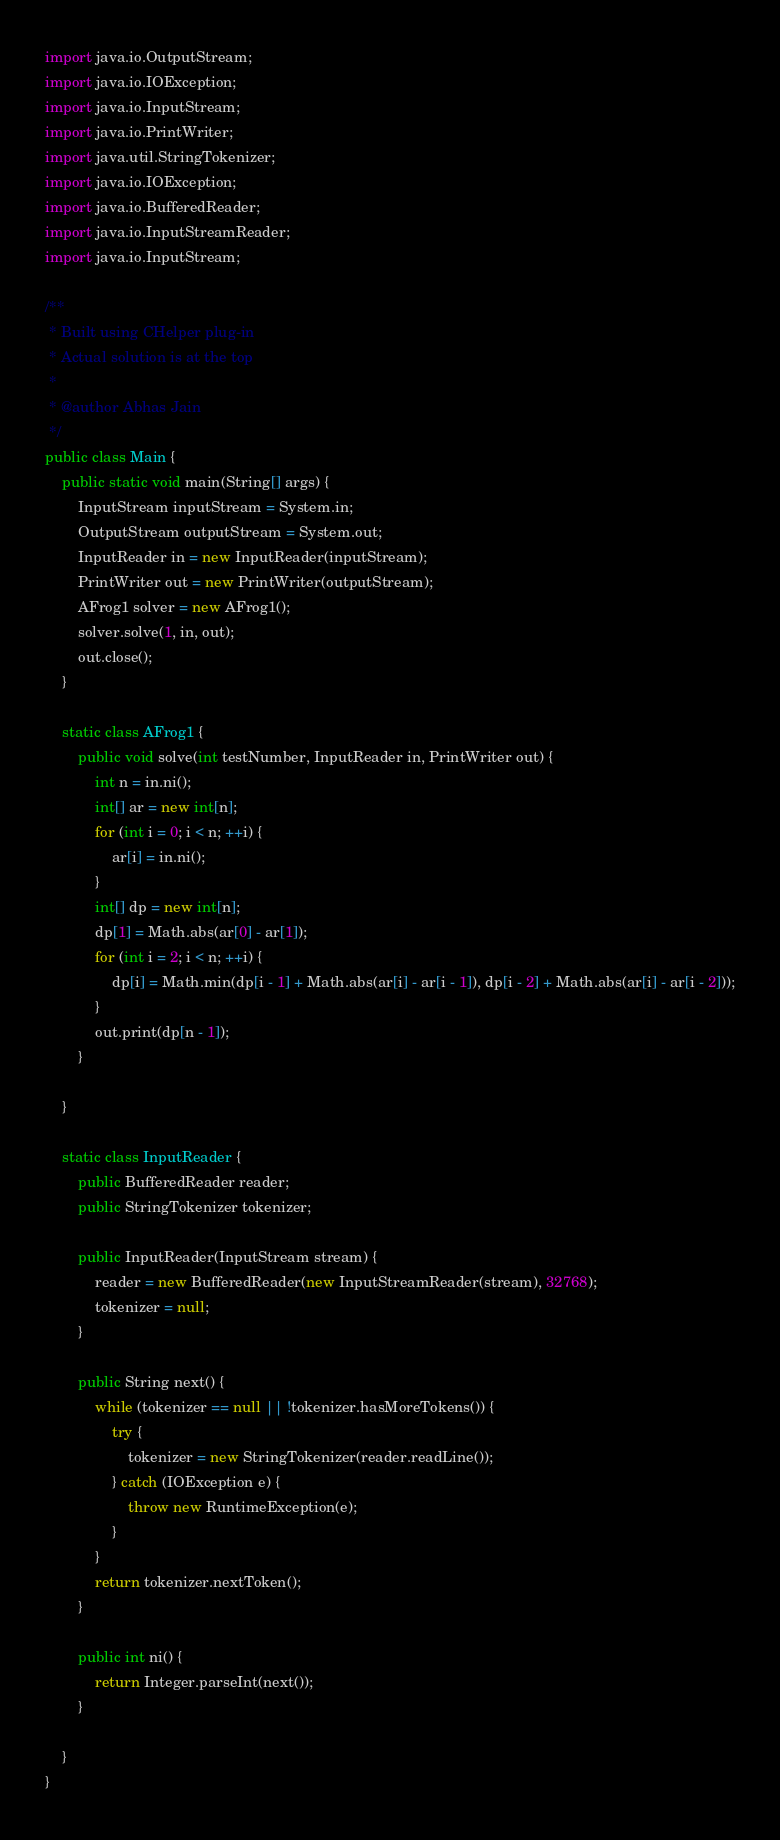Convert code to text. <code><loc_0><loc_0><loc_500><loc_500><_Java_>import java.io.OutputStream;
import java.io.IOException;
import java.io.InputStream;
import java.io.PrintWriter;
import java.util.StringTokenizer;
import java.io.IOException;
import java.io.BufferedReader;
import java.io.InputStreamReader;
import java.io.InputStream;

/**
 * Built using CHelper plug-in
 * Actual solution is at the top
 *
 * @author Abhas Jain
 */
public class Main {
    public static void main(String[] args) {
        InputStream inputStream = System.in;
        OutputStream outputStream = System.out;
        InputReader in = new InputReader(inputStream);
        PrintWriter out = new PrintWriter(outputStream);
        AFrog1 solver = new AFrog1();
        solver.solve(1, in, out);
        out.close();
    }

    static class AFrog1 {
        public void solve(int testNumber, InputReader in, PrintWriter out) {
            int n = in.ni();
            int[] ar = new int[n];
            for (int i = 0; i < n; ++i) {
                ar[i] = in.ni();
            }
            int[] dp = new int[n];
            dp[1] = Math.abs(ar[0] - ar[1]);
            for (int i = 2; i < n; ++i) {
                dp[i] = Math.min(dp[i - 1] + Math.abs(ar[i] - ar[i - 1]), dp[i - 2] + Math.abs(ar[i] - ar[i - 2]));
            }
            out.print(dp[n - 1]);
        }

    }

    static class InputReader {
        public BufferedReader reader;
        public StringTokenizer tokenizer;

        public InputReader(InputStream stream) {
            reader = new BufferedReader(new InputStreamReader(stream), 32768);
            tokenizer = null;
        }

        public String next() {
            while (tokenizer == null || !tokenizer.hasMoreTokens()) {
                try {
                    tokenizer = new StringTokenizer(reader.readLine());
                } catch (IOException e) {
                    throw new RuntimeException(e);
                }
            }
            return tokenizer.nextToken();
        }

        public int ni() {
            return Integer.parseInt(next());
        }

    }
}

</code> 